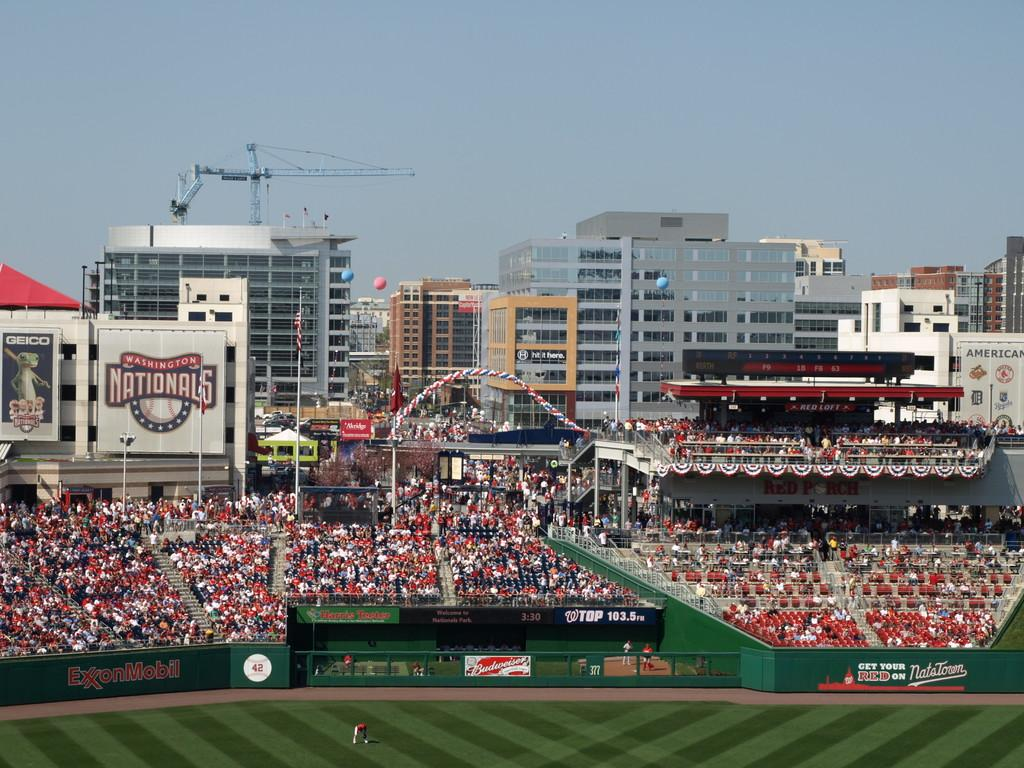<image>
Relay a brief, clear account of the picture shown. Baseball stadium full of fans from a distance, the home team is the nationals. 